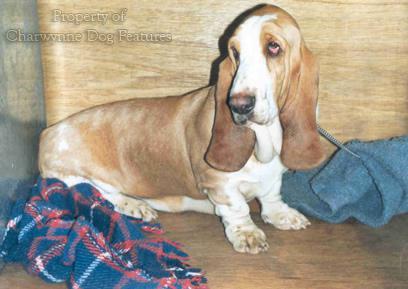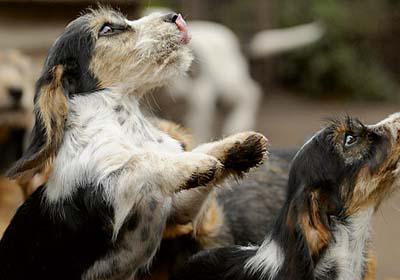The first image is the image on the left, the second image is the image on the right. Evaluate the accuracy of this statement regarding the images: "The right image includes a tri-color dog in an upright profile pose with its front paws raised off the ground.". Is it true? Answer yes or no. Yes. The first image is the image on the left, the second image is the image on the right. Analyze the images presented: Is the assertion "One of the images shows a dog with its two front paws off the ground." valid? Answer yes or no. Yes. 